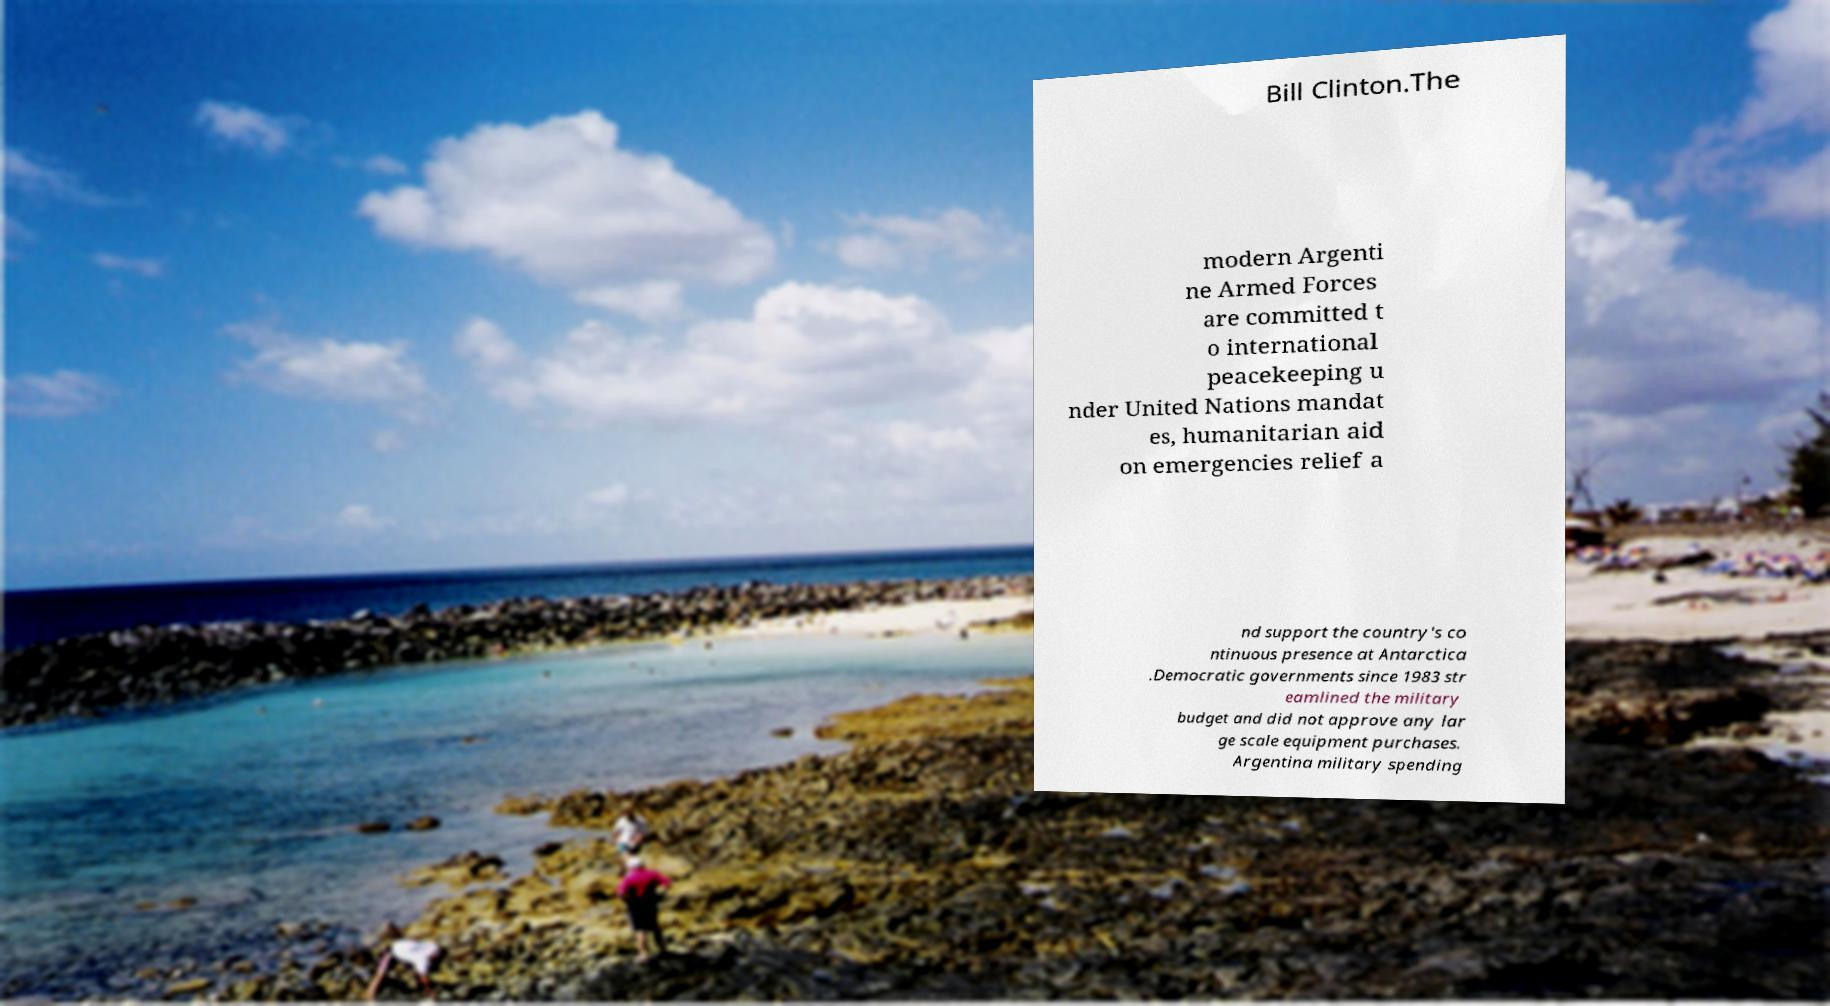There's text embedded in this image that I need extracted. Can you transcribe it verbatim? Bill Clinton.The modern Argenti ne Armed Forces are committed t o international peacekeeping u nder United Nations mandat es, humanitarian aid on emergencies relief a nd support the country's co ntinuous presence at Antarctica .Democratic governments since 1983 str eamlined the military budget and did not approve any lar ge scale equipment purchases. Argentina military spending 